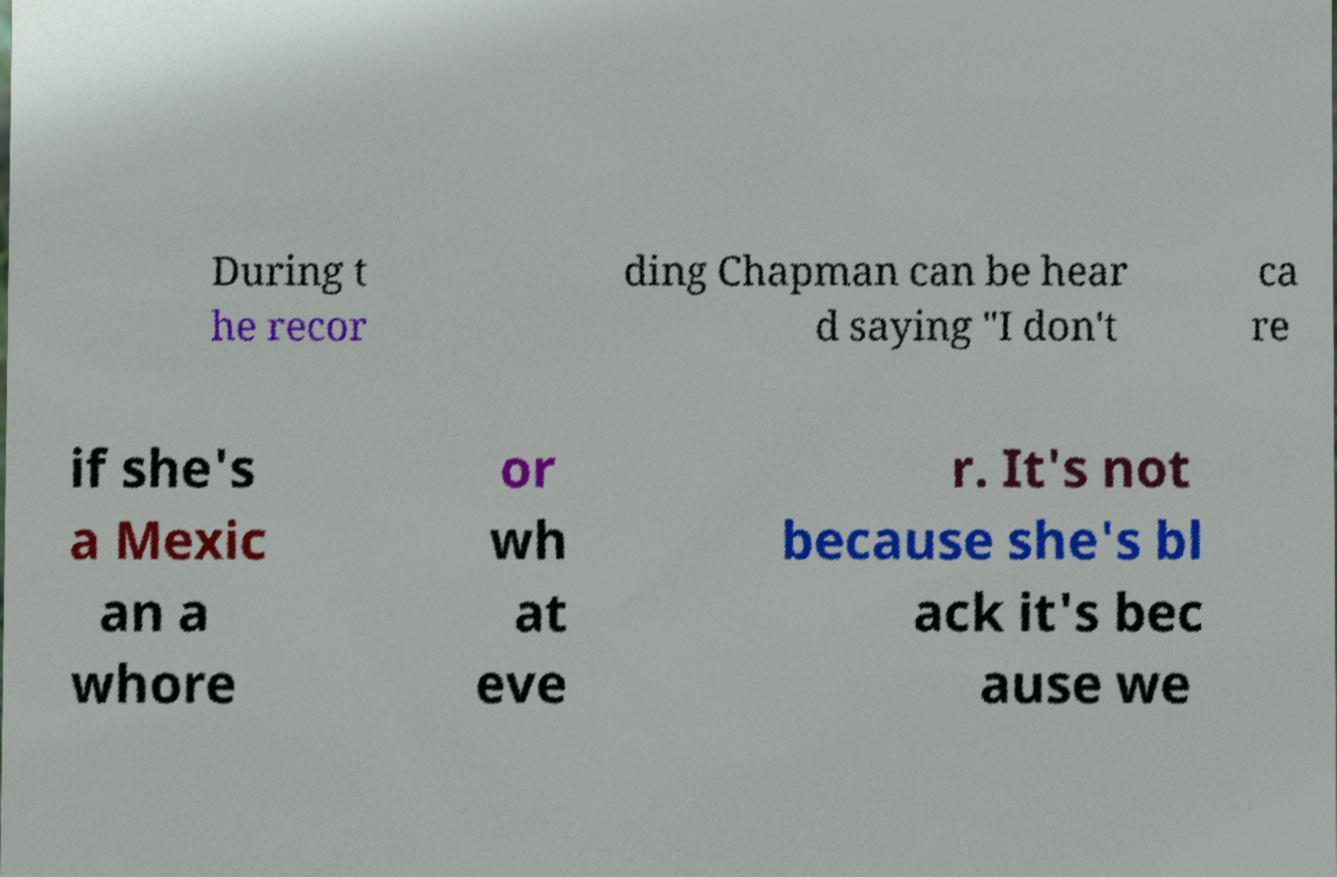Can you read and provide the text displayed in the image?This photo seems to have some interesting text. Can you extract and type it out for me? During t he recor ding Chapman can be hear d saying "I don't ca re if she's a Mexic an a whore or wh at eve r. It's not because she's bl ack it's bec ause we 